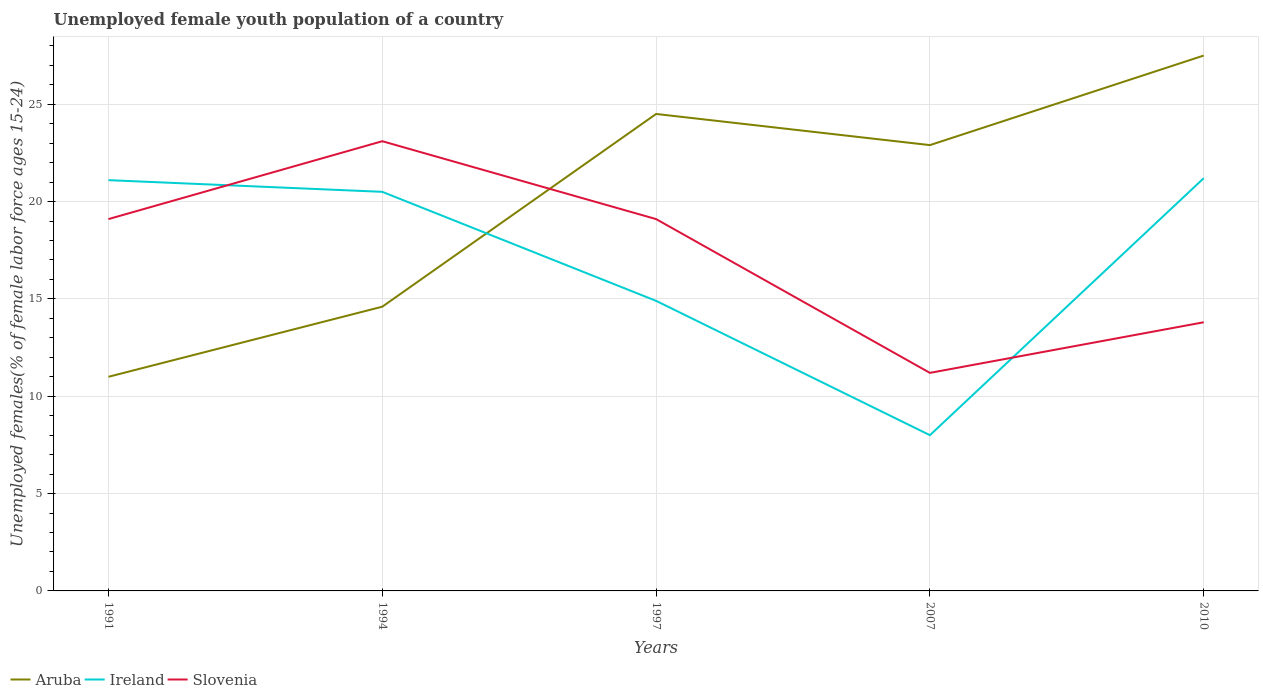How many different coloured lines are there?
Make the answer very short. 3. Does the line corresponding to Slovenia intersect with the line corresponding to Ireland?
Provide a short and direct response. Yes. What is the total percentage of unemployed female youth population in Ireland in the graph?
Your answer should be compact. -6.3. Is the percentage of unemployed female youth population in Slovenia strictly greater than the percentage of unemployed female youth population in Ireland over the years?
Ensure brevity in your answer.  No. Does the graph contain any zero values?
Ensure brevity in your answer.  No. Does the graph contain grids?
Your answer should be very brief. Yes. How many legend labels are there?
Provide a succinct answer. 3. How are the legend labels stacked?
Ensure brevity in your answer.  Horizontal. What is the title of the graph?
Offer a very short reply. Unemployed female youth population of a country. Does "Europe(developing only)" appear as one of the legend labels in the graph?
Provide a short and direct response. No. What is the label or title of the Y-axis?
Your response must be concise. Unemployed females(% of female labor force ages 15-24). What is the Unemployed females(% of female labor force ages 15-24) of Aruba in 1991?
Offer a very short reply. 11. What is the Unemployed females(% of female labor force ages 15-24) in Ireland in 1991?
Your answer should be compact. 21.1. What is the Unemployed females(% of female labor force ages 15-24) in Slovenia in 1991?
Your answer should be compact. 19.1. What is the Unemployed females(% of female labor force ages 15-24) of Aruba in 1994?
Keep it short and to the point. 14.6. What is the Unemployed females(% of female labor force ages 15-24) of Slovenia in 1994?
Provide a short and direct response. 23.1. What is the Unemployed females(% of female labor force ages 15-24) of Aruba in 1997?
Make the answer very short. 24.5. What is the Unemployed females(% of female labor force ages 15-24) of Ireland in 1997?
Your response must be concise. 14.9. What is the Unemployed females(% of female labor force ages 15-24) of Slovenia in 1997?
Offer a terse response. 19.1. What is the Unemployed females(% of female labor force ages 15-24) of Aruba in 2007?
Provide a short and direct response. 22.9. What is the Unemployed females(% of female labor force ages 15-24) in Slovenia in 2007?
Provide a succinct answer. 11.2. What is the Unemployed females(% of female labor force ages 15-24) of Ireland in 2010?
Provide a succinct answer. 21.2. What is the Unemployed females(% of female labor force ages 15-24) of Slovenia in 2010?
Make the answer very short. 13.8. Across all years, what is the maximum Unemployed females(% of female labor force ages 15-24) in Ireland?
Your response must be concise. 21.2. Across all years, what is the maximum Unemployed females(% of female labor force ages 15-24) in Slovenia?
Ensure brevity in your answer.  23.1. Across all years, what is the minimum Unemployed females(% of female labor force ages 15-24) in Aruba?
Ensure brevity in your answer.  11. Across all years, what is the minimum Unemployed females(% of female labor force ages 15-24) of Slovenia?
Keep it short and to the point. 11.2. What is the total Unemployed females(% of female labor force ages 15-24) in Aruba in the graph?
Offer a very short reply. 100.5. What is the total Unemployed females(% of female labor force ages 15-24) in Ireland in the graph?
Keep it short and to the point. 85.7. What is the total Unemployed females(% of female labor force ages 15-24) in Slovenia in the graph?
Make the answer very short. 86.3. What is the difference between the Unemployed females(% of female labor force ages 15-24) of Aruba in 1991 and that in 1994?
Keep it short and to the point. -3.6. What is the difference between the Unemployed females(% of female labor force ages 15-24) of Ireland in 1991 and that in 1994?
Offer a terse response. 0.6. What is the difference between the Unemployed females(% of female labor force ages 15-24) in Aruba in 1991 and that in 2007?
Make the answer very short. -11.9. What is the difference between the Unemployed females(% of female labor force ages 15-24) of Slovenia in 1991 and that in 2007?
Your answer should be compact. 7.9. What is the difference between the Unemployed females(% of female labor force ages 15-24) of Aruba in 1991 and that in 2010?
Provide a short and direct response. -16.5. What is the difference between the Unemployed females(% of female labor force ages 15-24) in Slovenia in 1991 and that in 2010?
Give a very brief answer. 5.3. What is the difference between the Unemployed females(% of female labor force ages 15-24) of Ireland in 1994 and that in 1997?
Your answer should be compact. 5.6. What is the difference between the Unemployed females(% of female labor force ages 15-24) in Aruba in 1994 and that in 2007?
Keep it short and to the point. -8.3. What is the difference between the Unemployed females(% of female labor force ages 15-24) in Ireland in 1994 and that in 2007?
Provide a short and direct response. 12.5. What is the difference between the Unemployed females(% of female labor force ages 15-24) of Aruba in 1994 and that in 2010?
Make the answer very short. -12.9. What is the difference between the Unemployed females(% of female labor force ages 15-24) in Slovenia in 1997 and that in 2007?
Your answer should be very brief. 7.9. What is the difference between the Unemployed females(% of female labor force ages 15-24) in Aruba in 2007 and that in 2010?
Make the answer very short. -4.6. What is the difference between the Unemployed females(% of female labor force ages 15-24) in Ireland in 2007 and that in 2010?
Make the answer very short. -13.2. What is the difference between the Unemployed females(% of female labor force ages 15-24) of Aruba in 1991 and the Unemployed females(% of female labor force ages 15-24) of Ireland in 1997?
Offer a terse response. -3.9. What is the difference between the Unemployed females(% of female labor force ages 15-24) in Aruba in 1991 and the Unemployed females(% of female labor force ages 15-24) in Slovenia in 1997?
Your answer should be compact. -8.1. What is the difference between the Unemployed females(% of female labor force ages 15-24) of Ireland in 1991 and the Unemployed females(% of female labor force ages 15-24) of Slovenia in 1997?
Your response must be concise. 2. What is the difference between the Unemployed females(% of female labor force ages 15-24) of Aruba in 1991 and the Unemployed females(% of female labor force ages 15-24) of Ireland in 2007?
Provide a succinct answer. 3. What is the difference between the Unemployed females(% of female labor force ages 15-24) in Aruba in 1994 and the Unemployed females(% of female labor force ages 15-24) in Slovenia in 1997?
Provide a short and direct response. -4.5. What is the difference between the Unemployed females(% of female labor force ages 15-24) in Aruba in 1994 and the Unemployed females(% of female labor force ages 15-24) in Ireland in 2007?
Make the answer very short. 6.6. What is the difference between the Unemployed females(% of female labor force ages 15-24) in Aruba in 1994 and the Unemployed females(% of female labor force ages 15-24) in Slovenia in 2007?
Make the answer very short. 3.4. What is the difference between the Unemployed females(% of female labor force ages 15-24) of Aruba in 1994 and the Unemployed females(% of female labor force ages 15-24) of Ireland in 2010?
Ensure brevity in your answer.  -6.6. What is the difference between the Unemployed females(% of female labor force ages 15-24) of Ireland in 1994 and the Unemployed females(% of female labor force ages 15-24) of Slovenia in 2010?
Offer a very short reply. 6.7. What is the difference between the Unemployed females(% of female labor force ages 15-24) in Ireland in 1997 and the Unemployed females(% of female labor force ages 15-24) in Slovenia in 2007?
Offer a very short reply. 3.7. What is the difference between the Unemployed females(% of female labor force ages 15-24) of Aruba in 1997 and the Unemployed females(% of female labor force ages 15-24) of Slovenia in 2010?
Your answer should be very brief. 10.7. What is the difference between the Unemployed females(% of female labor force ages 15-24) in Ireland in 1997 and the Unemployed females(% of female labor force ages 15-24) in Slovenia in 2010?
Give a very brief answer. 1.1. What is the difference between the Unemployed females(% of female labor force ages 15-24) in Aruba in 2007 and the Unemployed females(% of female labor force ages 15-24) in Ireland in 2010?
Provide a short and direct response. 1.7. What is the average Unemployed females(% of female labor force ages 15-24) of Aruba per year?
Provide a short and direct response. 20.1. What is the average Unemployed females(% of female labor force ages 15-24) of Ireland per year?
Make the answer very short. 17.14. What is the average Unemployed females(% of female labor force ages 15-24) in Slovenia per year?
Your answer should be very brief. 17.26. In the year 1991, what is the difference between the Unemployed females(% of female labor force ages 15-24) in Aruba and Unemployed females(% of female labor force ages 15-24) in Ireland?
Ensure brevity in your answer.  -10.1. In the year 1994, what is the difference between the Unemployed females(% of female labor force ages 15-24) in Aruba and Unemployed females(% of female labor force ages 15-24) in Slovenia?
Your answer should be very brief. -8.5. In the year 1997, what is the difference between the Unemployed females(% of female labor force ages 15-24) in Aruba and Unemployed females(% of female labor force ages 15-24) in Ireland?
Give a very brief answer. 9.6. In the year 1997, what is the difference between the Unemployed females(% of female labor force ages 15-24) in Aruba and Unemployed females(% of female labor force ages 15-24) in Slovenia?
Offer a very short reply. 5.4. In the year 1997, what is the difference between the Unemployed females(% of female labor force ages 15-24) of Ireland and Unemployed females(% of female labor force ages 15-24) of Slovenia?
Give a very brief answer. -4.2. In the year 2007, what is the difference between the Unemployed females(% of female labor force ages 15-24) in Aruba and Unemployed females(% of female labor force ages 15-24) in Ireland?
Your response must be concise. 14.9. In the year 2007, what is the difference between the Unemployed females(% of female labor force ages 15-24) in Aruba and Unemployed females(% of female labor force ages 15-24) in Slovenia?
Give a very brief answer. 11.7. In the year 2007, what is the difference between the Unemployed females(% of female labor force ages 15-24) of Ireland and Unemployed females(% of female labor force ages 15-24) of Slovenia?
Ensure brevity in your answer.  -3.2. In the year 2010, what is the difference between the Unemployed females(% of female labor force ages 15-24) of Ireland and Unemployed females(% of female labor force ages 15-24) of Slovenia?
Provide a succinct answer. 7.4. What is the ratio of the Unemployed females(% of female labor force ages 15-24) of Aruba in 1991 to that in 1994?
Ensure brevity in your answer.  0.75. What is the ratio of the Unemployed females(% of female labor force ages 15-24) in Ireland in 1991 to that in 1994?
Make the answer very short. 1.03. What is the ratio of the Unemployed females(% of female labor force ages 15-24) in Slovenia in 1991 to that in 1994?
Provide a succinct answer. 0.83. What is the ratio of the Unemployed females(% of female labor force ages 15-24) of Aruba in 1991 to that in 1997?
Provide a succinct answer. 0.45. What is the ratio of the Unemployed females(% of female labor force ages 15-24) in Ireland in 1991 to that in 1997?
Provide a succinct answer. 1.42. What is the ratio of the Unemployed females(% of female labor force ages 15-24) of Aruba in 1991 to that in 2007?
Your answer should be compact. 0.48. What is the ratio of the Unemployed females(% of female labor force ages 15-24) in Ireland in 1991 to that in 2007?
Make the answer very short. 2.64. What is the ratio of the Unemployed females(% of female labor force ages 15-24) in Slovenia in 1991 to that in 2007?
Make the answer very short. 1.71. What is the ratio of the Unemployed females(% of female labor force ages 15-24) in Slovenia in 1991 to that in 2010?
Give a very brief answer. 1.38. What is the ratio of the Unemployed females(% of female labor force ages 15-24) of Aruba in 1994 to that in 1997?
Your answer should be very brief. 0.6. What is the ratio of the Unemployed females(% of female labor force ages 15-24) in Ireland in 1994 to that in 1997?
Give a very brief answer. 1.38. What is the ratio of the Unemployed females(% of female labor force ages 15-24) in Slovenia in 1994 to that in 1997?
Provide a succinct answer. 1.21. What is the ratio of the Unemployed females(% of female labor force ages 15-24) in Aruba in 1994 to that in 2007?
Provide a succinct answer. 0.64. What is the ratio of the Unemployed females(% of female labor force ages 15-24) in Ireland in 1994 to that in 2007?
Provide a succinct answer. 2.56. What is the ratio of the Unemployed females(% of female labor force ages 15-24) in Slovenia in 1994 to that in 2007?
Ensure brevity in your answer.  2.06. What is the ratio of the Unemployed females(% of female labor force ages 15-24) in Aruba in 1994 to that in 2010?
Give a very brief answer. 0.53. What is the ratio of the Unemployed females(% of female labor force ages 15-24) in Slovenia in 1994 to that in 2010?
Provide a succinct answer. 1.67. What is the ratio of the Unemployed females(% of female labor force ages 15-24) of Aruba in 1997 to that in 2007?
Your response must be concise. 1.07. What is the ratio of the Unemployed females(% of female labor force ages 15-24) of Ireland in 1997 to that in 2007?
Offer a terse response. 1.86. What is the ratio of the Unemployed females(% of female labor force ages 15-24) in Slovenia in 1997 to that in 2007?
Offer a very short reply. 1.71. What is the ratio of the Unemployed females(% of female labor force ages 15-24) of Aruba in 1997 to that in 2010?
Offer a very short reply. 0.89. What is the ratio of the Unemployed females(% of female labor force ages 15-24) of Ireland in 1997 to that in 2010?
Give a very brief answer. 0.7. What is the ratio of the Unemployed females(% of female labor force ages 15-24) in Slovenia in 1997 to that in 2010?
Provide a short and direct response. 1.38. What is the ratio of the Unemployed females(% of female labor force ages 15-24) in Aruba in 2007 to that in 2010?
Provide a succinct answer. 0.83. What is the ratio of the Unemployed females(% of female labor force ages 15-24) in Ireland in 2007 to that in 2010?
Keep it short and to the point. 0.38. What is the ratio of the Unemployed females(% of female labor force ages 15-24) in Slovenia in 2007 to that in 2010?
Provide a short and direct response. 0.81. What is the difference between the highest and the second highest Unemployed females(% of female labor force ages 15-24) in Ireland?
Offer a very short reply. 0.1. What is the difference between the highest and the second highest Unemployed females(% of female labor force ages 15-24) in Slovenia?
Give a very brief answer. 4. What is the difference between the highest and the lowest Unemployed females(% of female labor force ages 15-24) of Ireland?
Your answer should be very brief. 13.2. What is the difference between the highest and the lowest Unemployed females(% of female labor force ages 15-24) of Slovenia?
Offer a terse response. 11.9. 